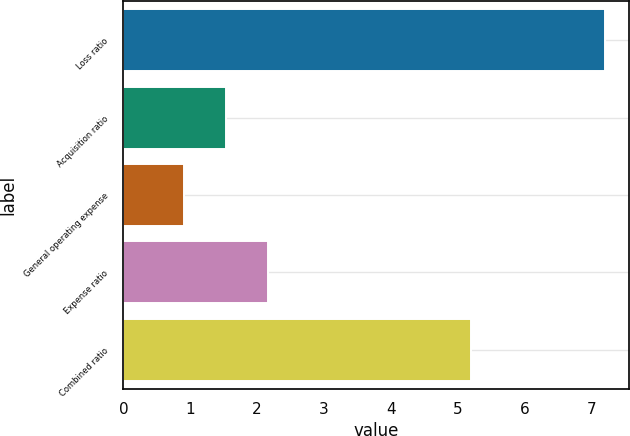<chart> <loc_0><loc_0><loc_500><loc_500><bar_chart><fcel>Loss ratio<fcel>Acquisition ratio<fcel>General operating expense<fcel>Expense ratio<fcel>Combined ratio<nl><fcel>7.2<fcel>1.53<fcel>0.9<fcel>2.16<fcel>5.2<nl></chart> 